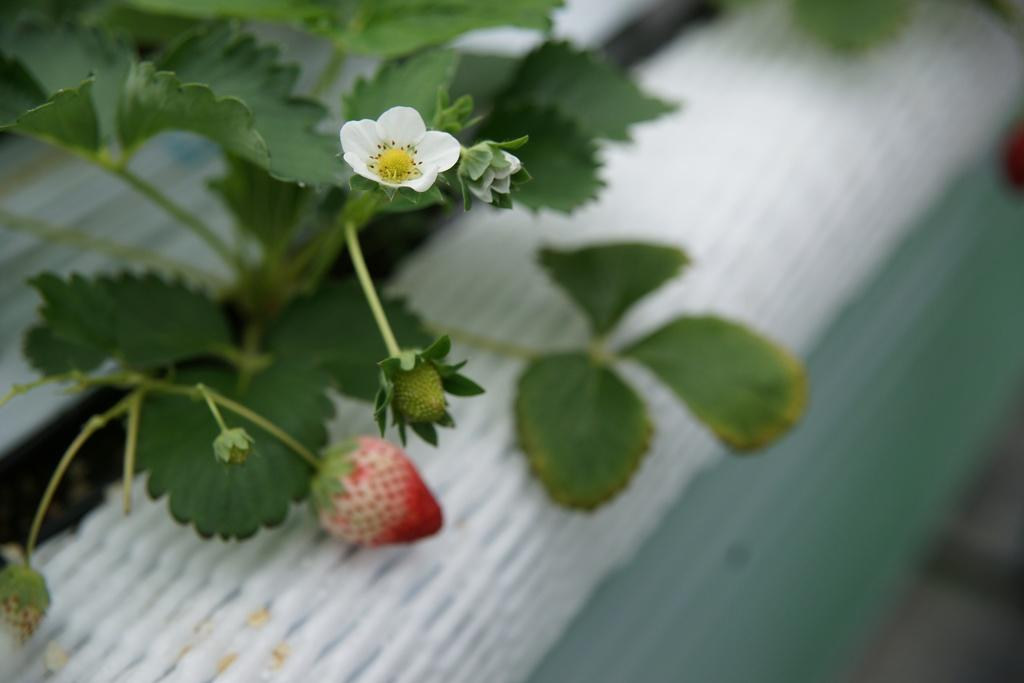What type of plants are in the image? There are flowers with stems and leaves in the image. What fruit is present in the image? There is a strawberry in the image. How would you describe the background of the image? The background of the image has a blurred view. What type of shoes can be seen in the image? There are no shoes present in the image. What type of wine is being served in the image? There is no wine present in the image. 